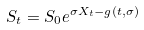Convert formula to latex. <formula><loc_0><loc_0><loc_500><loc_500>S _ { t } = S _ { 0 } e ^ { \sigma X _ { t } - g ( t , \sigma ) }</formula> 